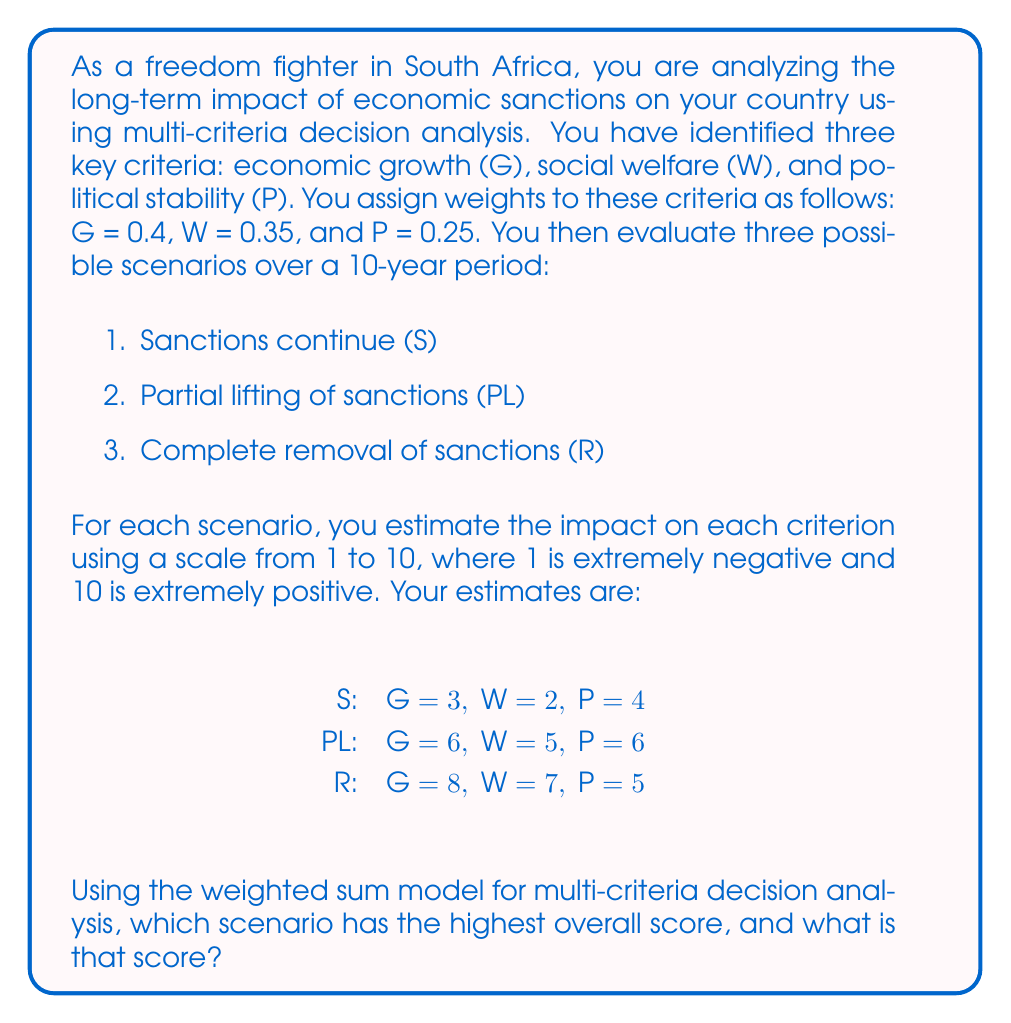Help me with this question. To solve this problem using multi-criteria decision analysis with the weighted sum model, we need to follow these steps:

1. Identify the criteria and their weights:
   - Economic growth (G): 0.4
   - Social welfare (W): 0.35
   - Political stability (P): 0.25

2. List the scenarios and their scores for each criterion:
   - Sanctions continue (S): G = 3, W = 2, P = 4
   - Partial lifting of sanctions (PL): G = 6, W = 5, P = 6
   - Complete removal of sanctions (R): G = 8, W = 7, P = 5

3. Calculate the weighted score for each scenario using the formula:

   $$ \text{Weighted Score} = \sum_{i=1}^n w_i \cdot x_i $$

   Where $w_i$ is the weight of criterion $i$, and $x_i$ is the score for that criterion.

4. Calculate the weighted score for each scenario:

   For S:
   $$ \text{Score}_S = 0.4 \cdot 3 + 0.35 \cdot 2 + 0.25 \cdot 4 = 1.2 + 0.7 + 1 = 2.9 $$

   For PL:
   $$ \text{Score}_{PL} = 0.4 \cdot 6 + 0.35 \cdot 5 + 0.25 \cdot 6 = 2.4 + 1.75 + 1.5 = 5.65 $$

   For R:
   $$ \text{Score}_R = 0.4 \cdot 8 + 0.35 \cdot 7 + 0.25 \cdot 5 = 3.2 + 2.45 + 1.25 = 6.9 $$

5. Compare the weighted scores to determine the highest overall score.
Answer: The scenario with the highest overall score is the Complete removal of sanctions (R) with a score of 6.9. 